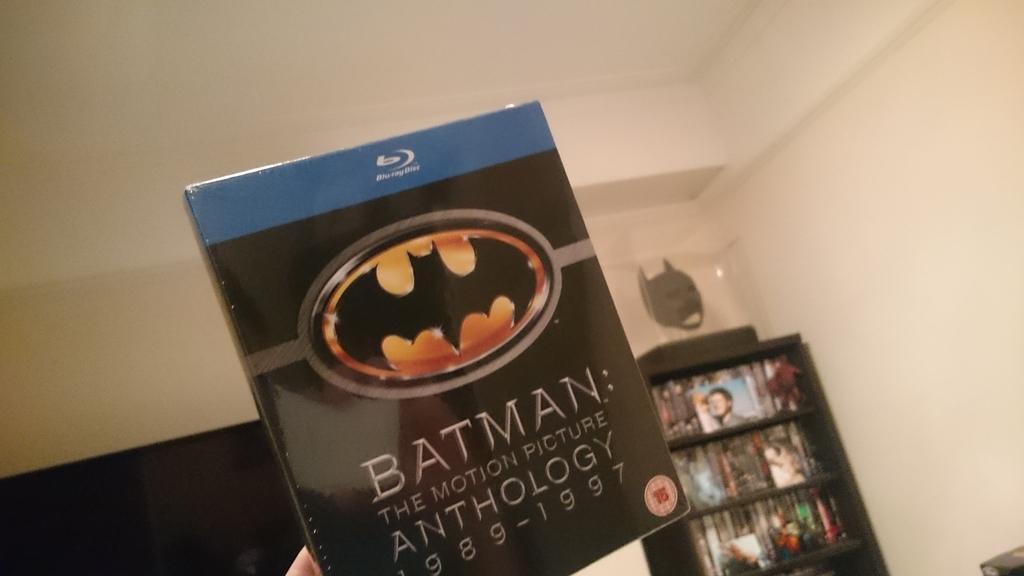What superhero is featured in this motion picture?
Give a very brief answer. Batman. Is this a blu-ray?
Ensure brevity in your answer.  Yes. 